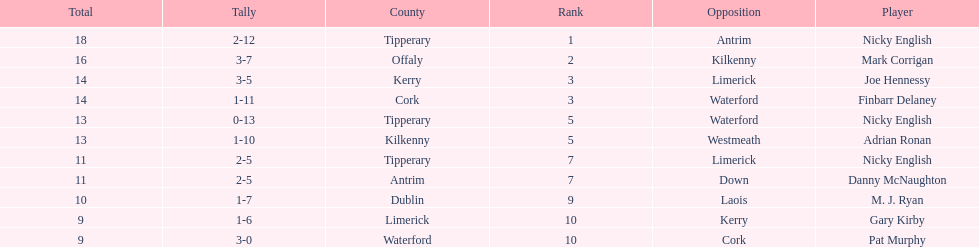What was the average of the totals of nicky english and mark corrigan? 17. 